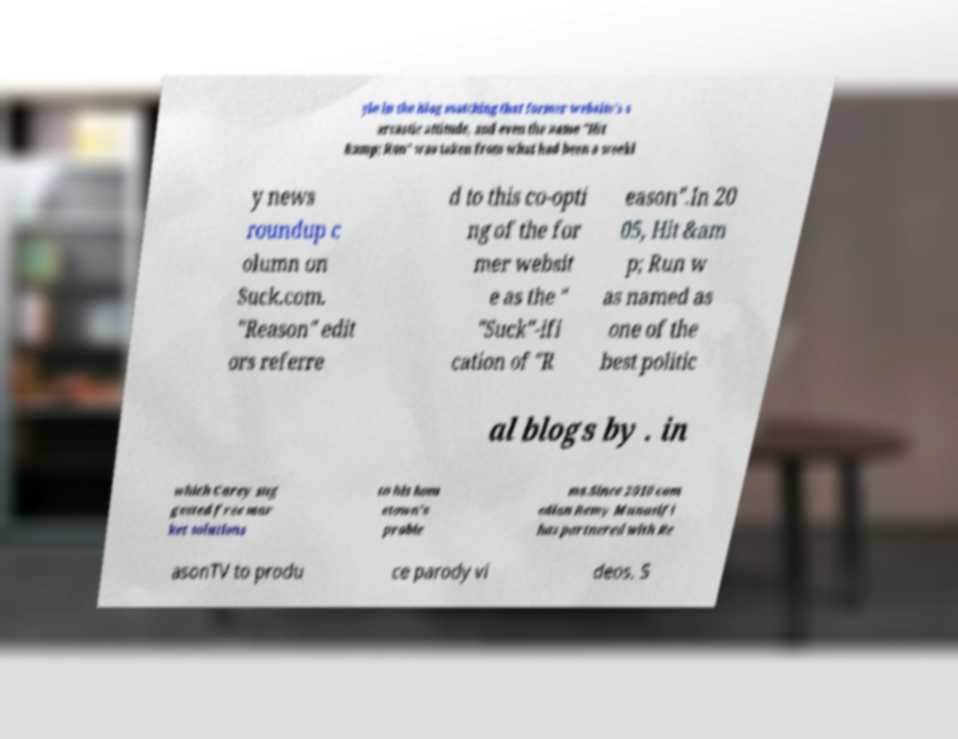Could you extract and type out the text from this image? yle in the blog matching that former website's s arcastic attitude, and even the name "Hit &amp; Run" was taken from what had been a weekl y news roundup c olumn on Suck.com. "Reason" edit ors referre d to this co-opti ng of the for mer websit e as the " "Suck"-ifi cation of "R eason".In 20 05, Hit &am p; Run w as named as one of the best politic al blogs by . in which Carey sug gested free mar ket solutions to his hom etown's proble ms.Since 2010 com edian Remy Munasifi has partnered with Re asonTV to produ ce parody vi deos. S 